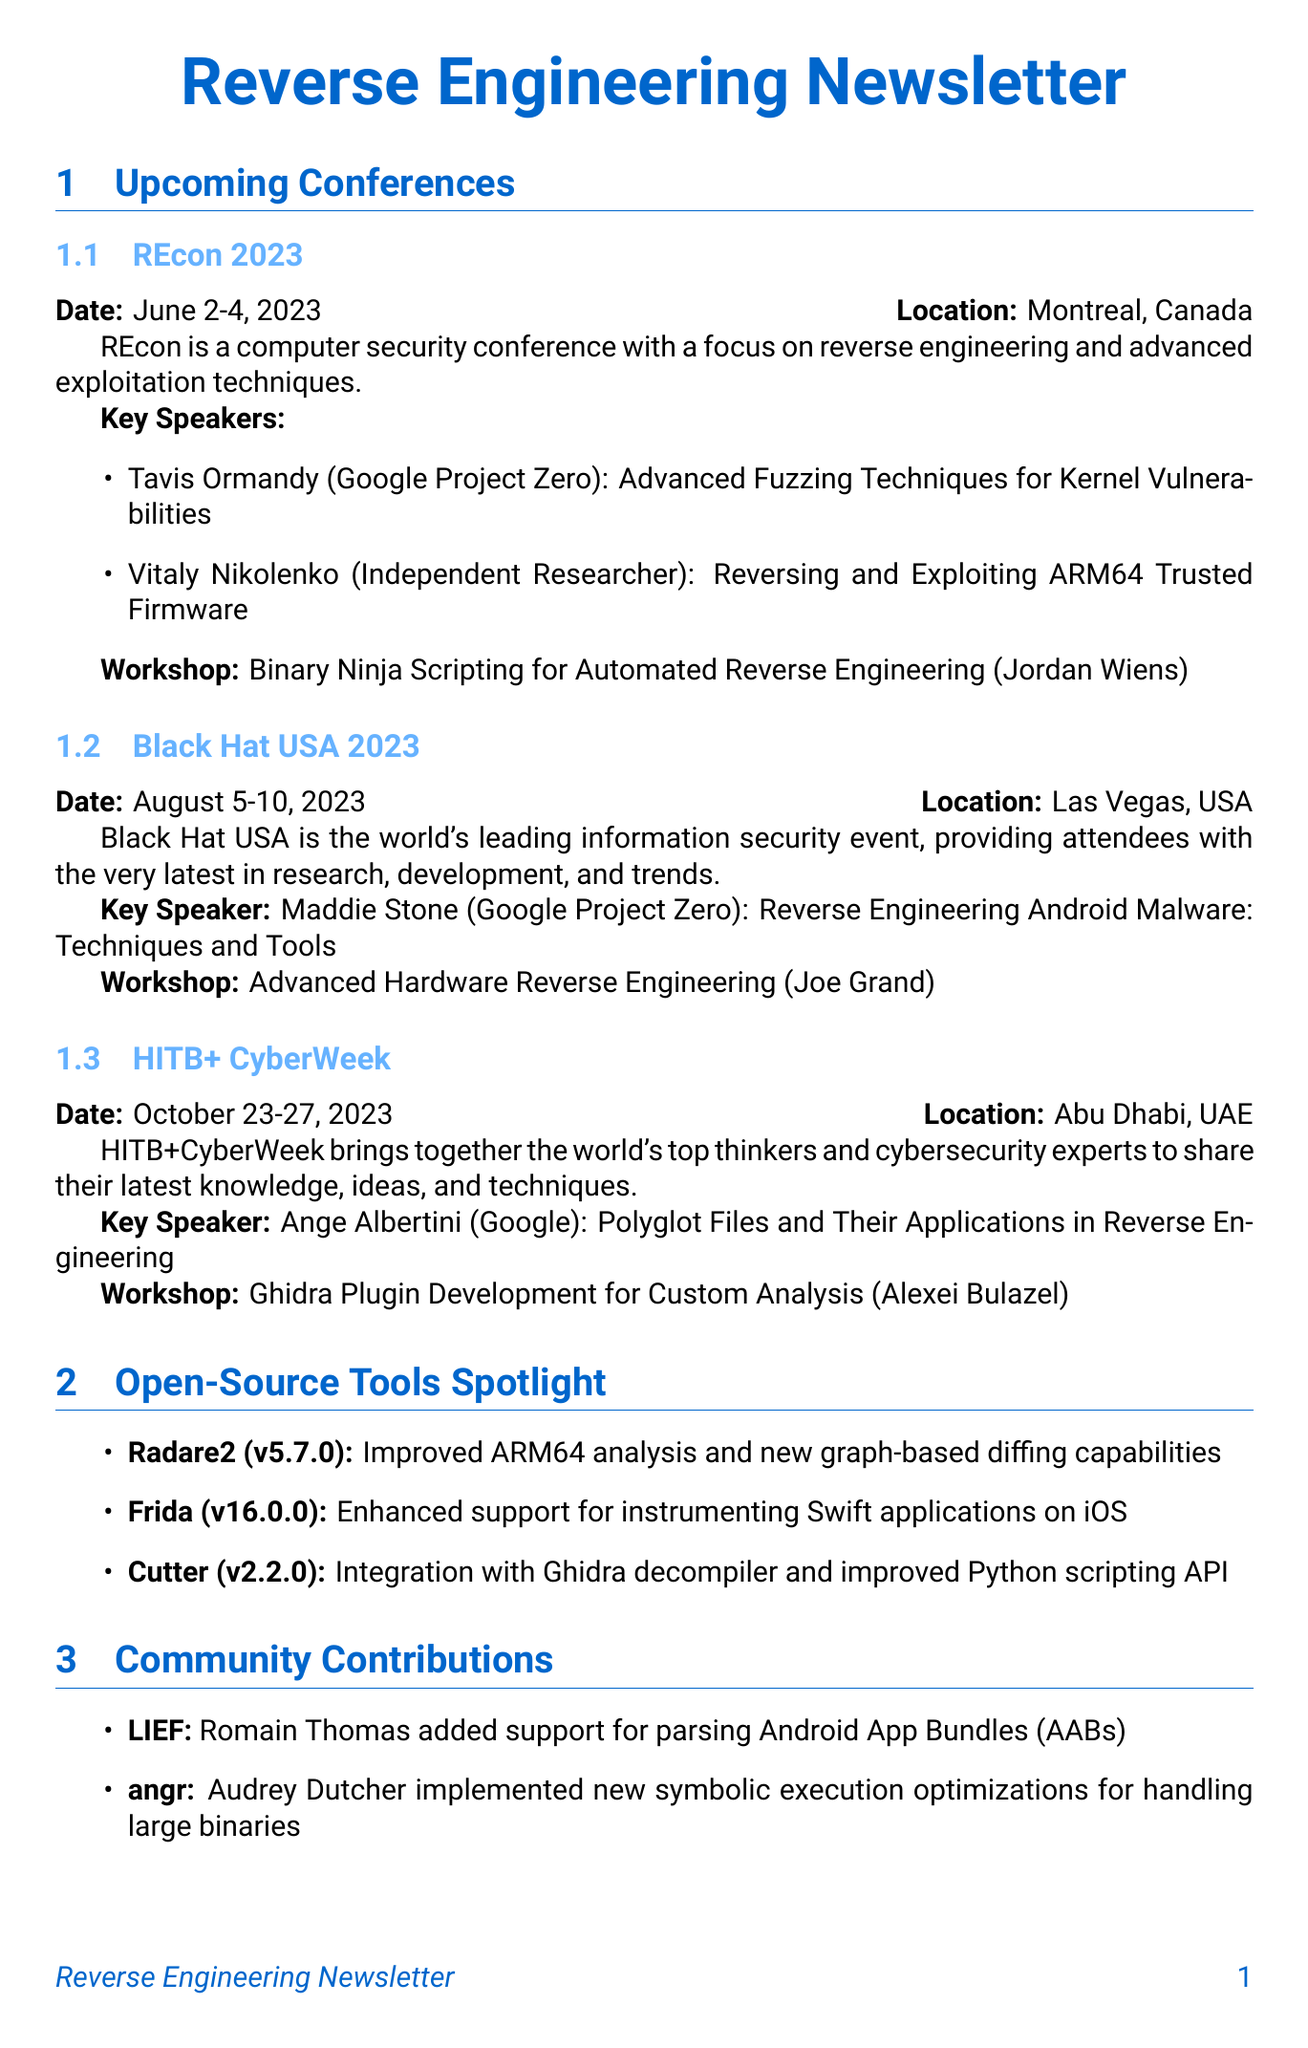What are the dates for REcon 2023? The document specifies the dates for REcon 2023 as June 2-4, 2023.
Answer: June 2-4, 2023 Who is the instructor for the workshop at HITB+ CyberWeek? The document lists Alexei Bulazel as the instructor for the workshop at HITB+ CyberWeek.
Answer: Alexei Bulazel What is the main topic of Maddie Stone's presentation at Black Hat USA 2023? The document states that Maddie Stone's presentation focuses on "Reverse Engineering Android Malware: Techniques and Tools."
Answer: Reverse Engineering Android Malware: Techniques and Tools Which open-source tool has improved ARM64 analysis? The document mentions Radare2 as the tool that has improved ARM64 analysis.
Answer: Radare2 How many conferences are listed in the newsletter? The document outlines three conferences: REcon 2023, Black Hat USA 2023, and HITB+ CyberWeek.
Answer: Three Who contributed to the LIEF project? Romain Thomas is identified in the document as the contributor to the LIEF project.
Answer: Romain Thomas What is the version number of Frida highlighted in the document? The document provides the version number of Frida as 16.0.0.
Answer: 16.0.0 What is the focus of the "Open-Source Tools Spotlight" section? This section discusses the latest updates and releases in open-source reverse engineering tools.
Answer: Latest updates and releases in open-source reverse engineering tools 